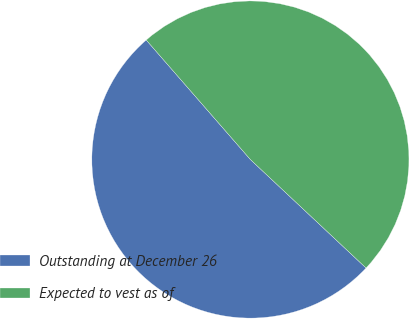<chart> <loc_0><loc_0><loc_500><loc_500><pie_chart><fcel>Outstanding at December 26<fcel>Expected to vest as of<nl><fcel>51.6%<fcel>48.4%<nl></chart> 